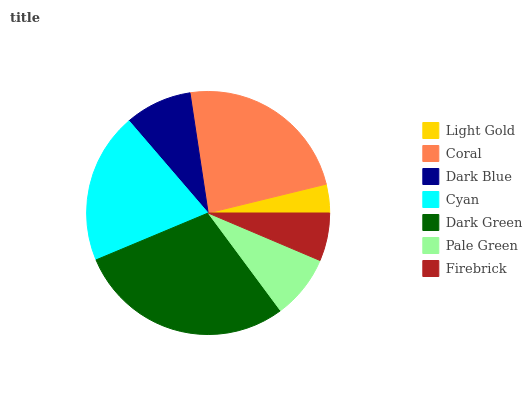Is Light Gold the minimum?
Answer yes or no. Yes. Is Dark Green the maximum?
Answer yes or no. Yes. Is Coral the minimum?
Answer yes or no. No. Is Coral the maximum?
Answer yes or no. No. Is Coral greater than Light Gold?
Answer yes or no. Yes. Is Light Gold less than Coral?
Answer yes or no. Yes. Is Light Gold greater than Coral?
Answer yes or no. No. Is Coral less than Light Gold?
Answer yes or no. No. Is Dark Blue the high median?
Answer yes or no. Yes. Is Dark Blue the low median?
Answer yes or no. Yes. Is Pale Green the high median?
Answer yes or no. No. Is Coral the low median?
Answer yes or no. No. 